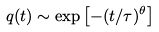<formula> <loc_0><loc_0><loc_500><loc_500>q ( t ) \sim \exp \left [ - ( t / \tau ) ^ { \theta } \right ]</formula> 